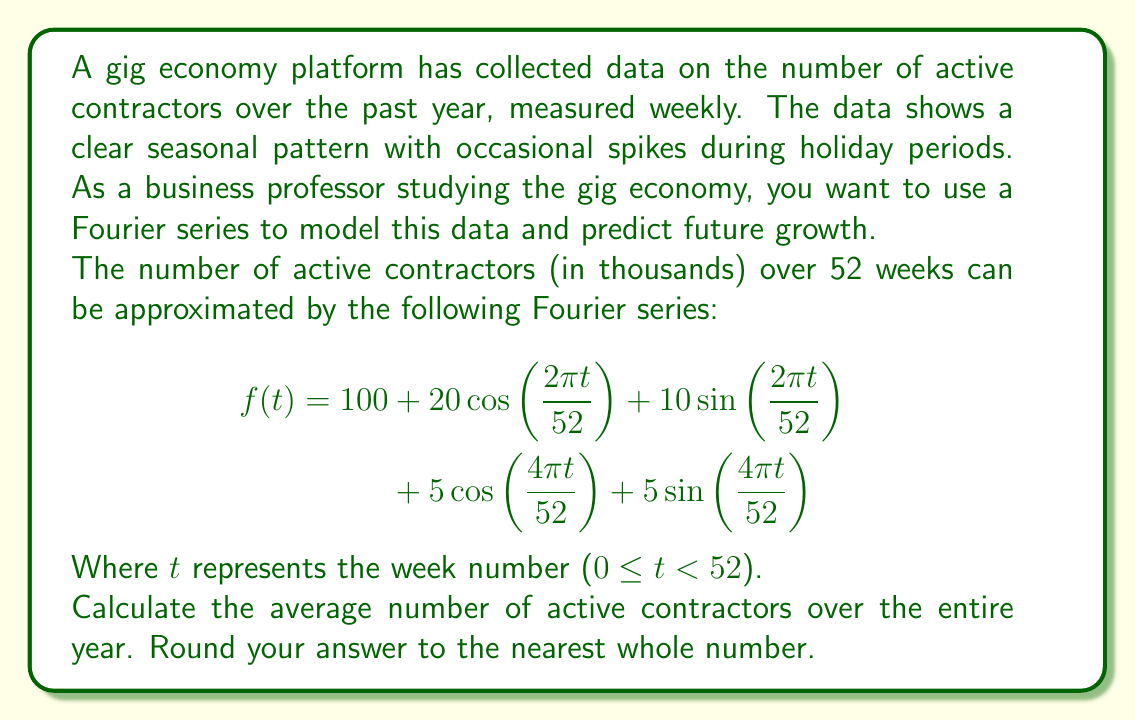Teach me how to tackle this problem. To find the average number of active contractors over the entire year, we need to calculate the mean value of the Fourier series over its period. For a Fourier series, the mean value is equal to the constant term (a₀) in the series.

Let's break down the given Fourier series:

$$f(t) = 100 + 20\cos\left(\frac{2\pi t}{52}\right) + 10\sin\left(\frac{2\pi t}{52}\right) + 5\cos\left(\frac{4\pi t}{52}\right) + 5\sin\left(\frac{4\pi t}{52}\right)$$

In this series:
- The constant term a₀ = 100
- Other terms are periodic functions with zero mean over a complete period

The cosine and sine terms will oscillate above and below zero, but their average over a complete period is always zero. Therefore, these terms do not contribute to the overall average.

The average number of active contractors over the entire year is simply the constant term:

Average = a₀ = 100

Since the question asks for the answer in thousands and rounded to the nearest whole number, our final answer is 100 thousand active contractors.

This result indicates that while there are seasonal fluctuations and holiday spikes, the gig economy platform maintains an average of 100,000 active contractors throughout the year, demonstrating a stable base of independent workers.
Answer: 100 